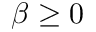<formula> <loc_0><loc_0><loc_500><loc_500>\beta \geq 0</formula> 